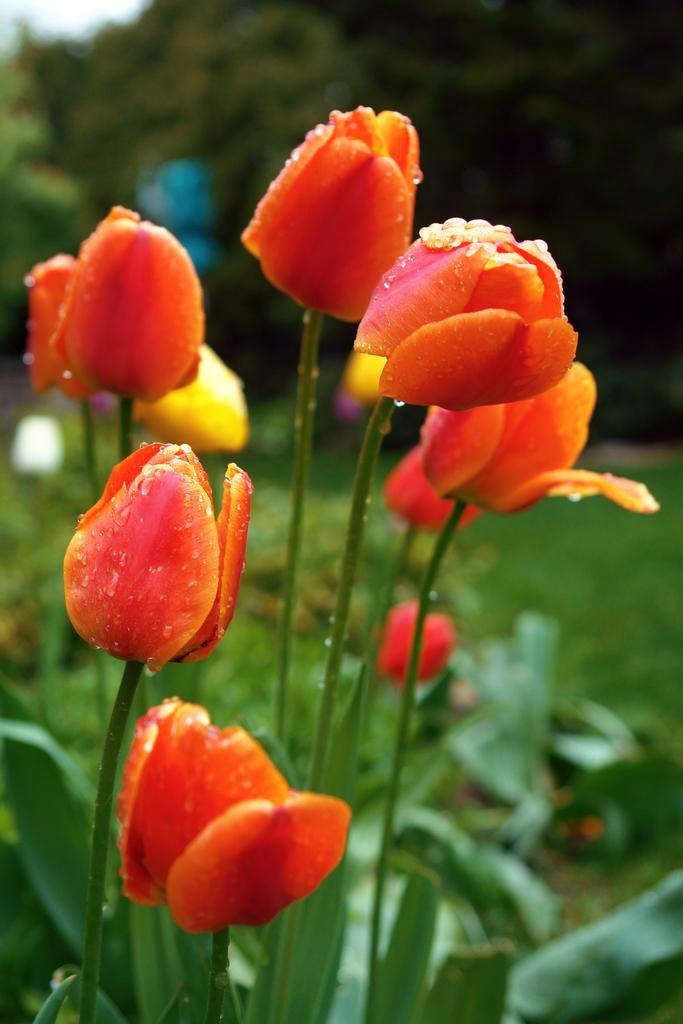What type of flora can be seen in the image? There are flowers on plants in the image. What type of vegetation is visible in the image besides the flowers? There are trees visible in the image. Can you see a gun in the image? No, there is no gun present in the image. Is there a tiger visible in the image? No, there is no tiger present in the image. 